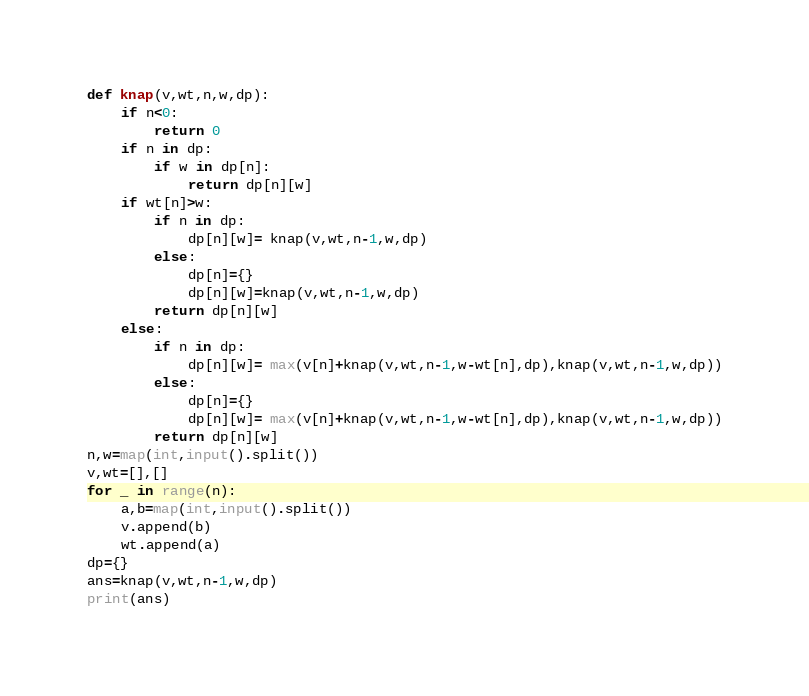<code> <loc_0><loc_0><loc_500><loc_500><_Python_>def knap(v,wt,n,w,dp):
    if n<0:
        return 0
    if n in dp:
        if w in dp[n]:
            return dp[n][w]
    if wt[n]>w:
        if n in dp:
            dp[n][w]= knap(v,wt,n-1,w,dp)
        else:
            dp[n]={}
            dp[n][w]=knap(v,wt,n-1,w,dp)
        return dp[n][w]
    else:
        if n in dp:
            dp[n][w]= max(v[n]+knap(v,wt,n-1,w-wt[n],dp),knap(v,wt,n-1,w,dp))
        else:
            dp[n]={}
            dp[n][w]= max(v[n]+knap(v,wt,n-1,w-wt[n],dp),knap(v,wt,n-1,w,dp))
        return dp[n][w]
n,w=map(int,input().split())
v,wt=[],[]
for _ in range(n):
    a,b=map(int,input().split())
    v.append(b)
    wt.append(a)
dp={}
ans=knap(v,wt,n-1,w,dp)
print(ans)</code> 